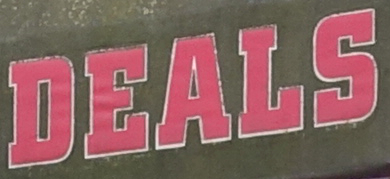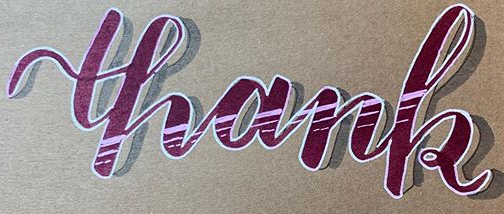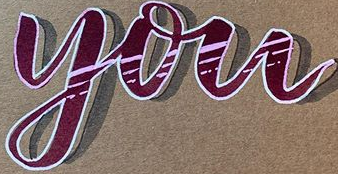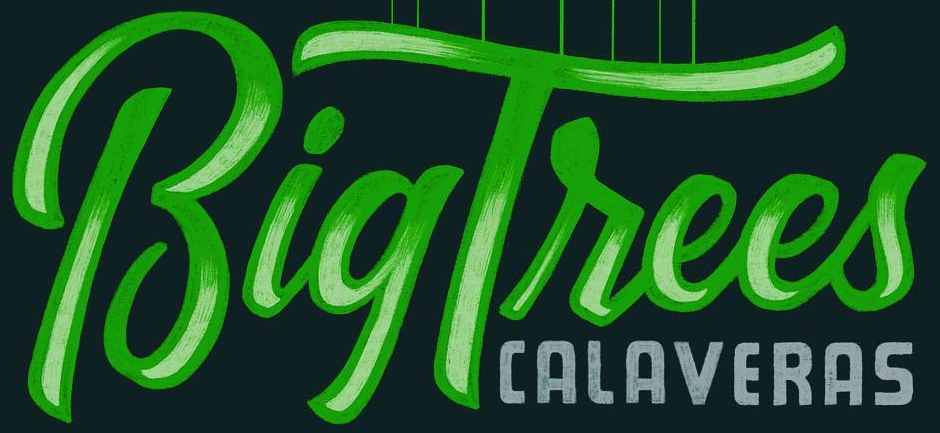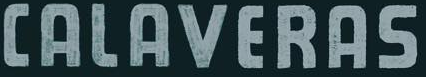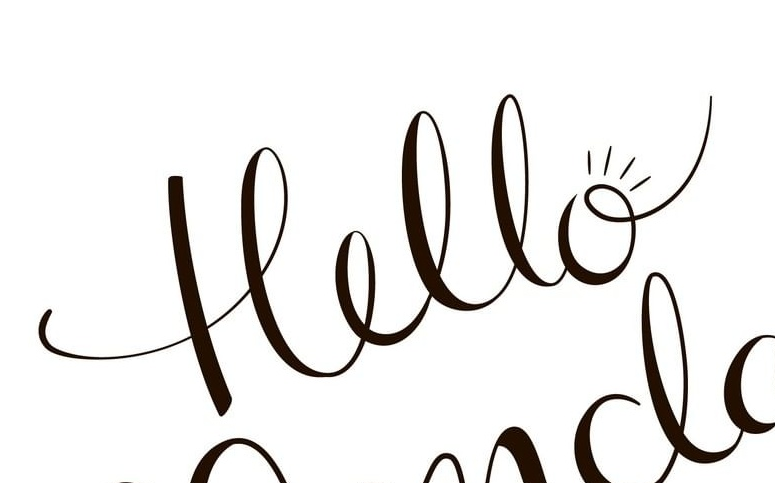Identify the words shown in these images in order, separated by a semicolon. DEALS; thank; you; BigTrees; CALAVERAS; Hello 